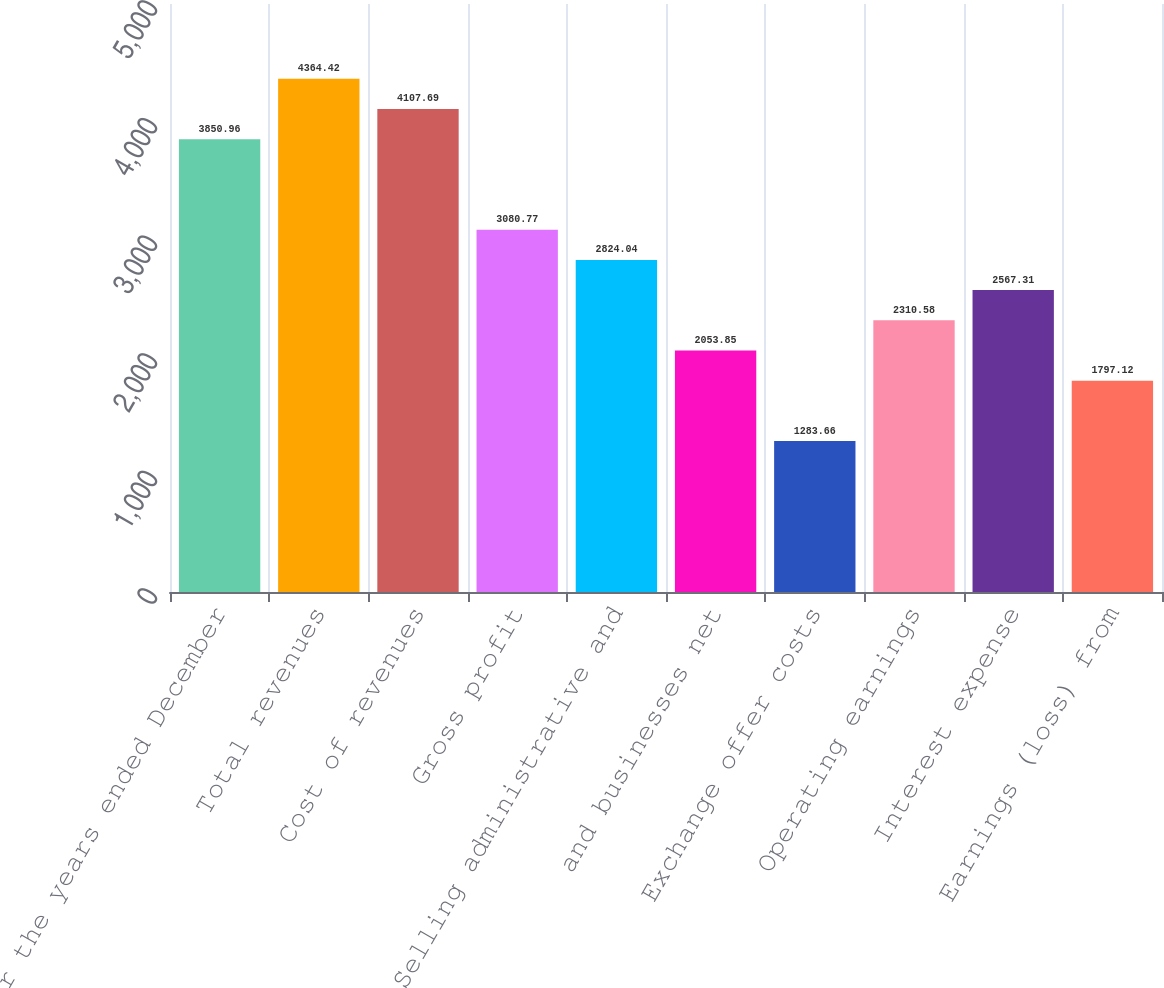<chart> <loc_0><loc_0><loc_500><loc_500><bar_chart><fcel>For the years ended December<fcel>Total revenues<fcel>Cost of revenues<fcel>Gross profit<fcel>Selling administrative and<fcel>and businesses net<fcel>Exchange offer costs<fcel>Operating earnings<fcel>Interest expense<fcel>Earnings (loss) from<nl><fcel>3850.96<fcel>4364.42<fcel>4107.69<fcel>3080.77<fcel>2824.04<fcel>2053.85<fcel>1283.66<fcel>2310.58<fcel>2567.31<fcel>1797.12<nl></chart> 